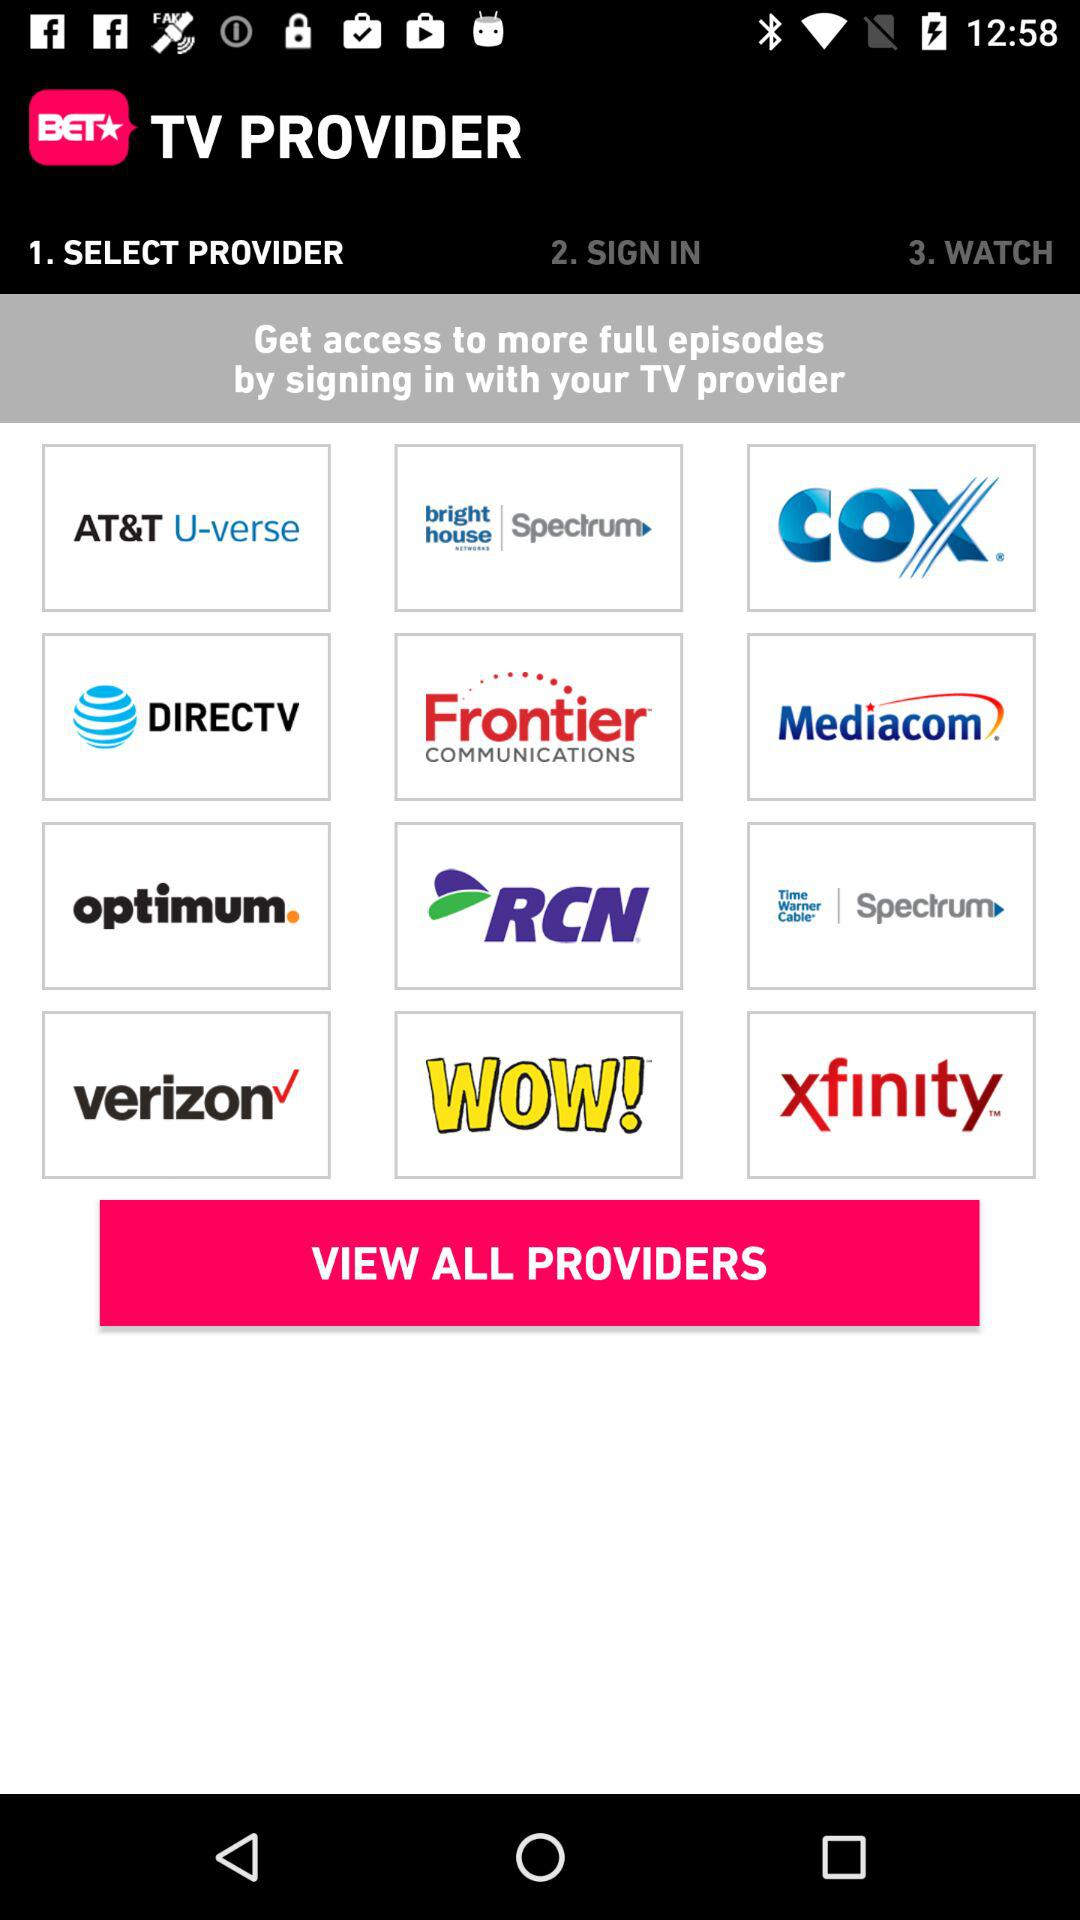Which option has been selected? The selected option is "1. SELECT PROVIDER". 